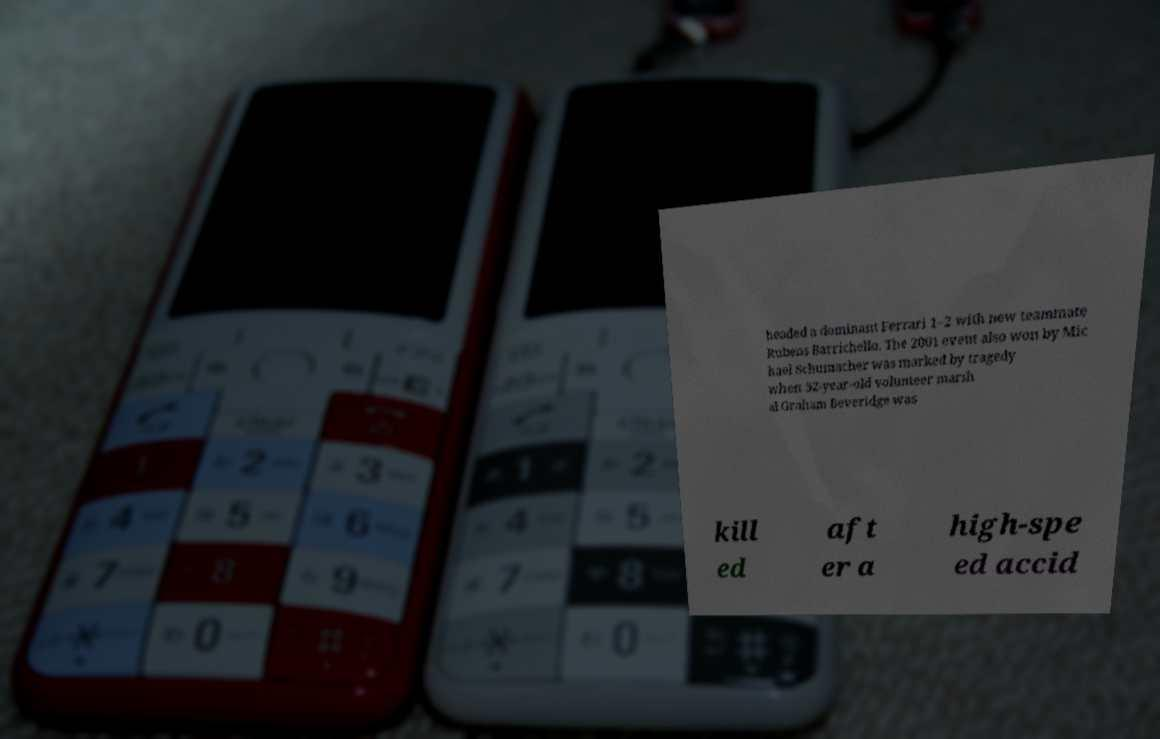I need the written content from this picture converted into text. Can you do that? headed a dominant Ferrari 1–2 with new teammate Rubens Barrichello. The 2001 event also won by Mic hael Schumacher was marked by tragedy when 52-year-old volunteer marsh al Graham Beveridge was kill ed aft er a high-spe ed accid 